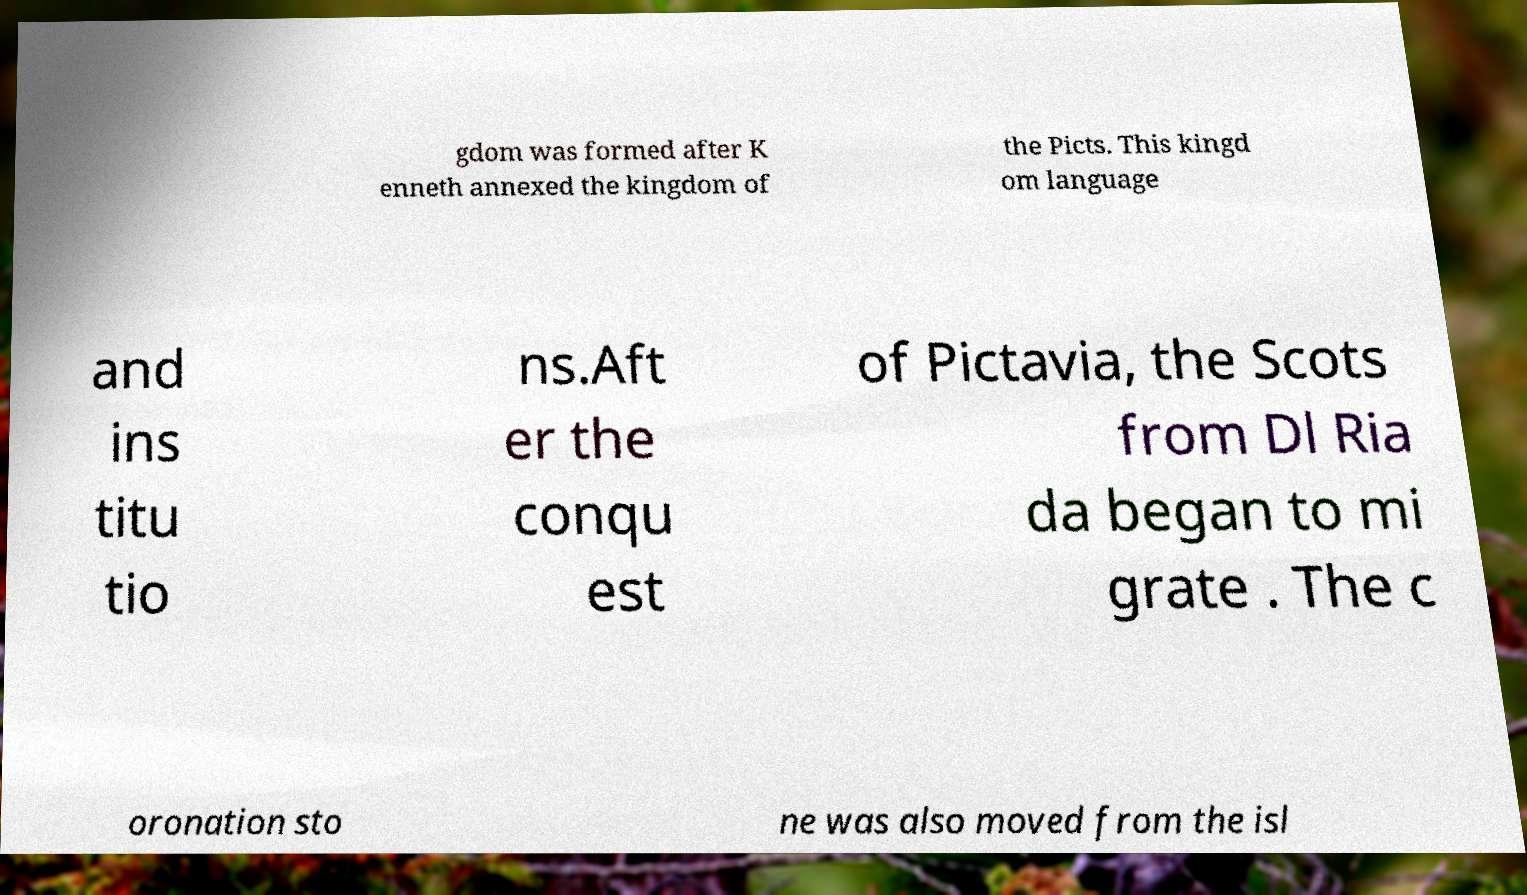Please identify and transcribe the text found in this image. gdom was formed after K enneth annexed the kingdom of the Picts. This kingd om language and ins titu tio ns.Aft er the conqu est of Pictavia, the Scots from Dl Ria da began to mi grate . The c oronation sto ne was also moved from the isl 